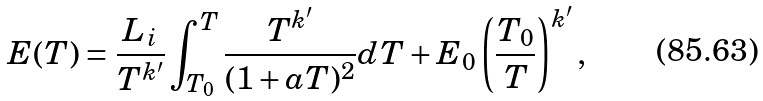Convert formula to latex. <formula><loc_0><loc_0><loc_500><loc_500>E ( T ) = \frac { L _ { i } } { T ^ { k ^ { \prime } } } \int _ { T _ { 0 } } ^ { T } \frac { T ^ { k ^ { \prime } } } { ( 1 + a T ) ^ { 2 } } d T + E _ { 0 } \left ( \frac { T _ { 0 } } { T } \right ) ^ { k ^ { \prime } } ,</formula> 